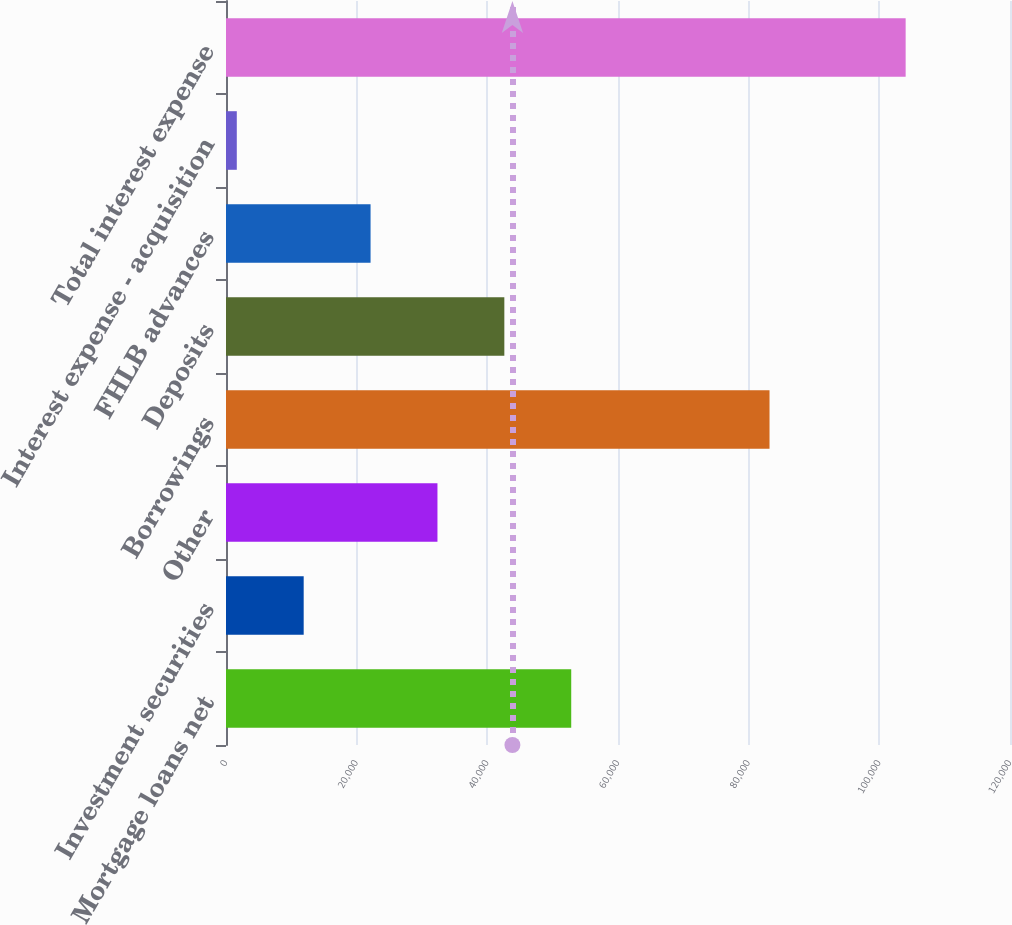<chart> <loc_0><loc_0><loc_500><loc_500><bar_chart><fcel>Mortgage loans net<fcel>Investment securities<fcel>Other<fcel>Borrowings<fcel>Deposits<fcel>FHLB advances<fcel>Interest expense - acquisition<fcel>Total interest expense<nl><fcel>52840.5<fcel>11890.5<fcel>32365.5<fcel>83193<fcel>42603<fcel>22128<fcel>1653<fcel>104028<nl></chart> 